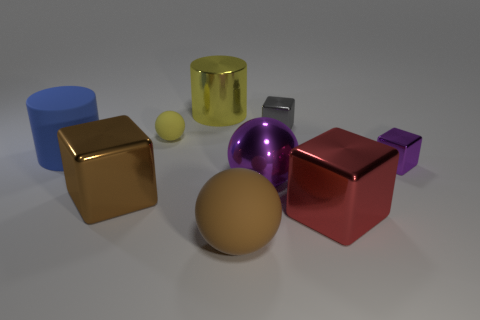Are there the same number of big yellow metal cylinders left of the yellow shiny cylinder and cyan blocks?
Your answer should be compact. Yes. Is there any other thing that is made of the same material as the tiny gray object?
Ensure brevity in your answer.  Yes. There is a tiny matte object; is it the same color as the big cylinder on the left side of the big yellow cylinder?
Your response must be concise. No. Are there any big blue things in front of the rubber thing left of the big shiny cube that is behind the red block?
Keep it short and to the point. No. Are there fewer big yellow things right of the small purple thing than tiny purple cubes?
Your response must be concise. Yes. How many other things are the same shape as the big yellow thing?
Your answer should be very brief. 1. What number of things are either big objects in front of the blue rubber cylinder or tiny objects that are in front of the large blue rubber cylinder?
Make the answer very short. 5. There is a shiny thing that is behind the red thing and on the right side of the gray metallic block; what size is it?
Ensure brevity in your answer.  Small. Does the blue thing that is left of the small purple cube have the same shape as the small purple thing?
Provide a short and direct response. No. There is a cylinder on the left side of the metallic block on the left side of the tiny metal block behind the purple cube; what size is it?
Your answer should be compact. Large. 